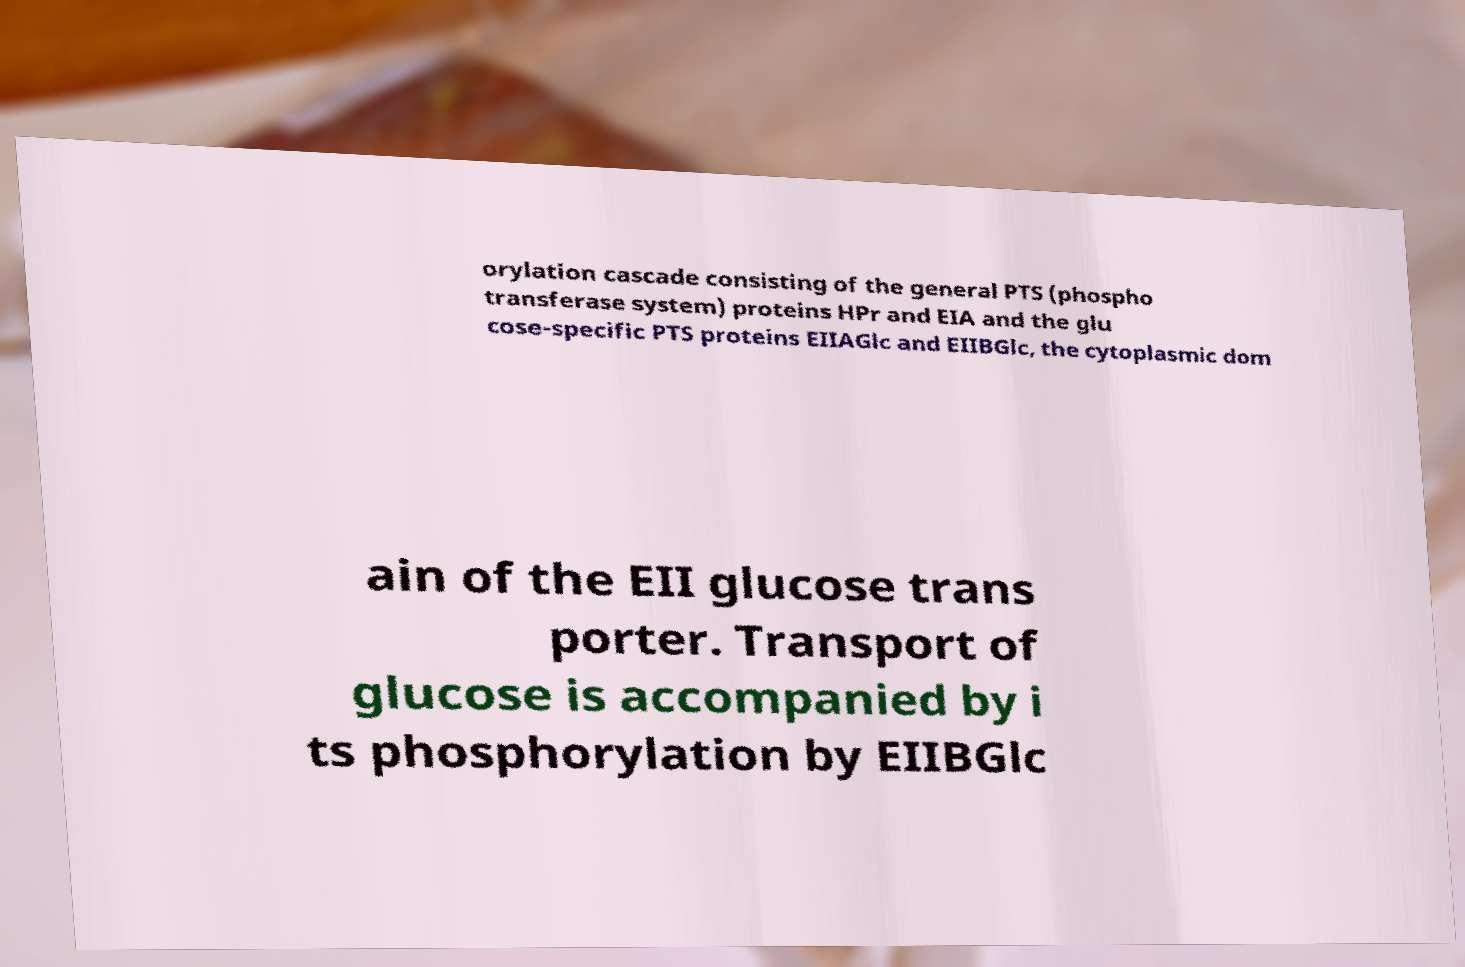Can you accurately transcribe the text from the provided image for me? orylation cascade consisting of the general PTS (phospho transferase system) proteins HPr and EIA and the glu cose-specific PTS proteins EIIAGlc and EIIBGlc, the cytoplasmic dom ain of the EII glucose trans porter. Transport of glucose is accompanied by i ts phosphorylation by EIIBGlc 